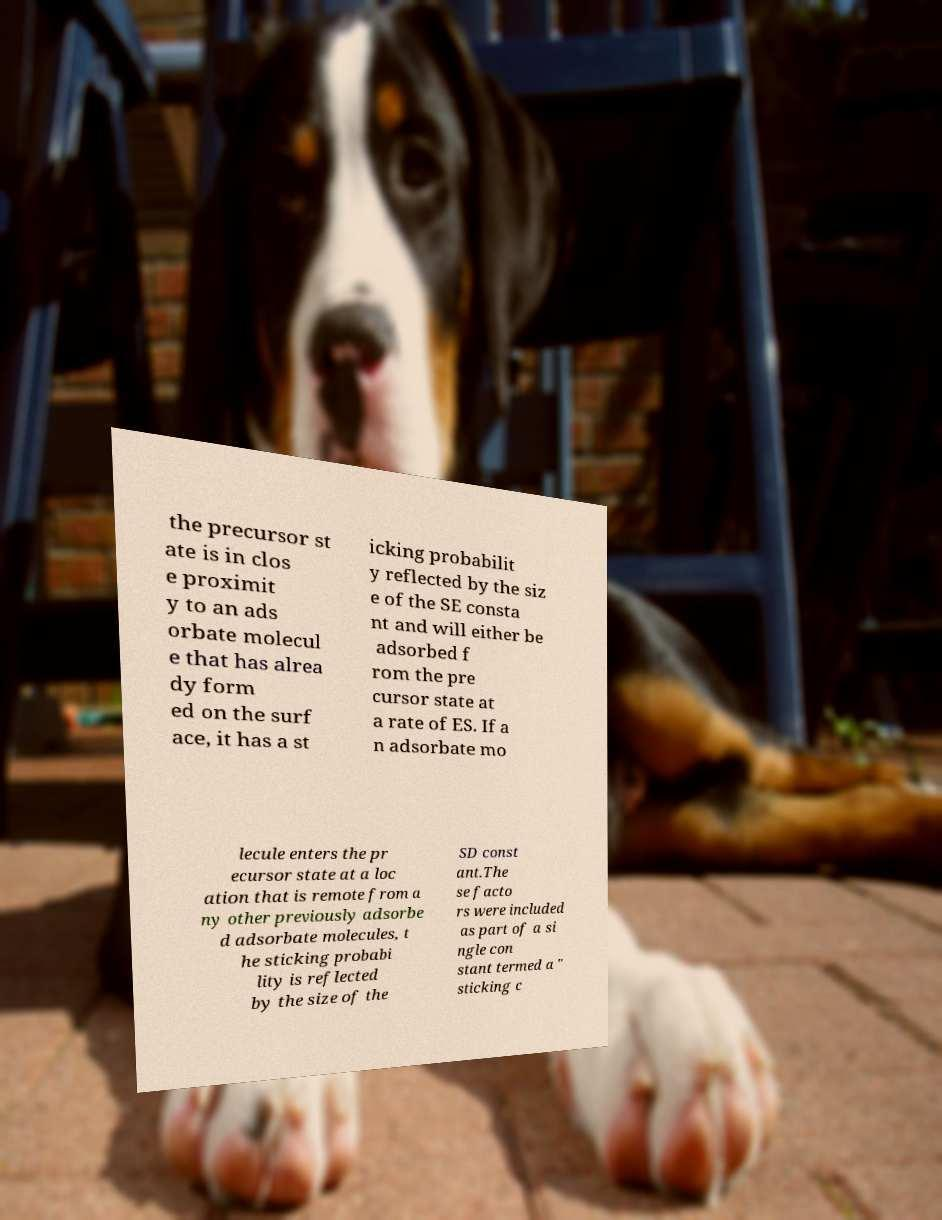I need the written content from this picture converted into text. Can you do that? the precursor st ate is in clos e proximit y to an ads orbate molecul e that has alrea dy form ed on the surf ace, it has a st icking probabilit y reflected by the siz e of the SE consta nt and will either be adsorbed f rom the pre cursor state at a rate of ES. If a n adsorbate mo lecule enters the pr ecursor state at a loc ation that is remote from a ny other previously adsorbe d adsorbate molecules, t he sticking probabi lity is reflected by the size of the SD const ant.The se facto rs were included as part of a si ngle con stant termed a " sticking c 